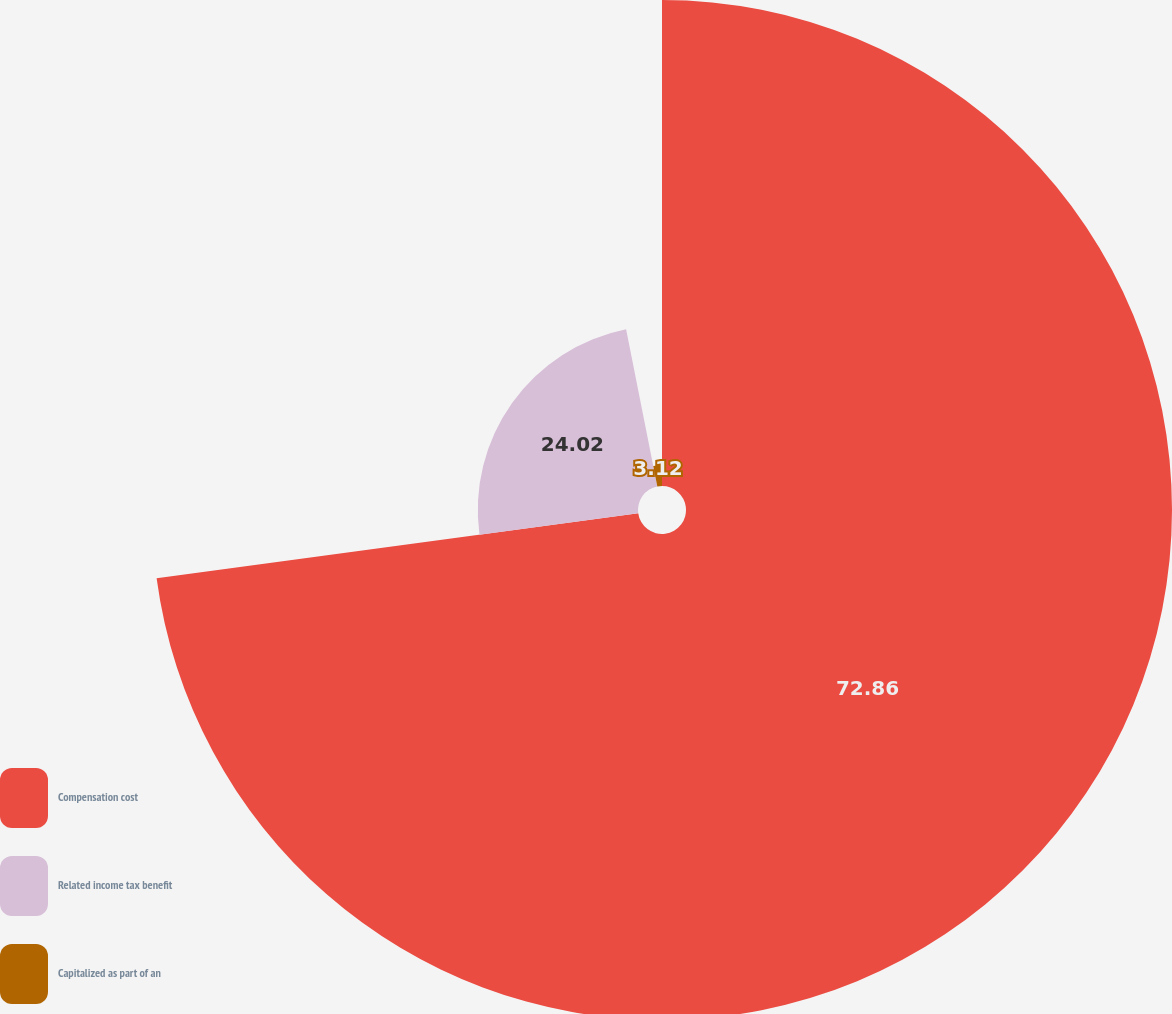Convert chart to OTSL. <chart><loc_0><loc_0><loc_500><loc_500><pie_chart><fcel>Compensation cost<fcel>Related income tax benefit<fcel>Capitalized as part of an<nl><fcel>72.86%<fcel>24.02%<fcel>3.12%<nl></chart> 